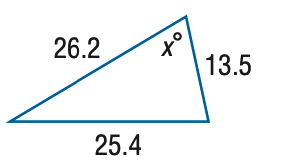Answer the mathemtical geometry problem and directly provide the correct option letter.
Question: Find x. Round the angle measure to the nearest degree.
Choices: A: 68 B: 72 C: 76 D: 80 B 